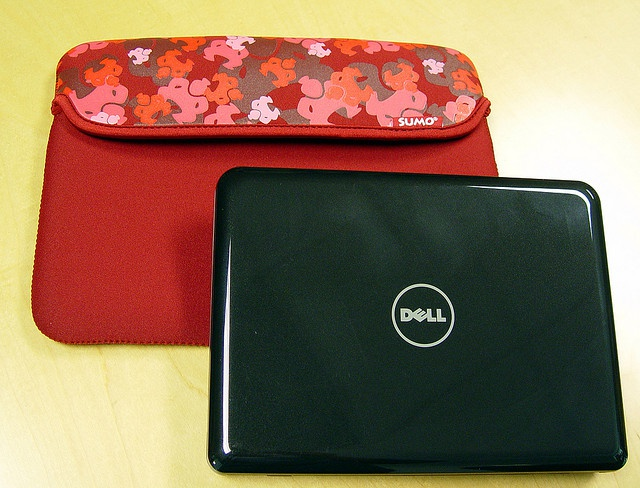Describe the objects in this image and their specific colors. I can see laptop in khaki, black, darkgreen, purple, and white tones and handbag in khaki, brown, and salmon tones in this image. 